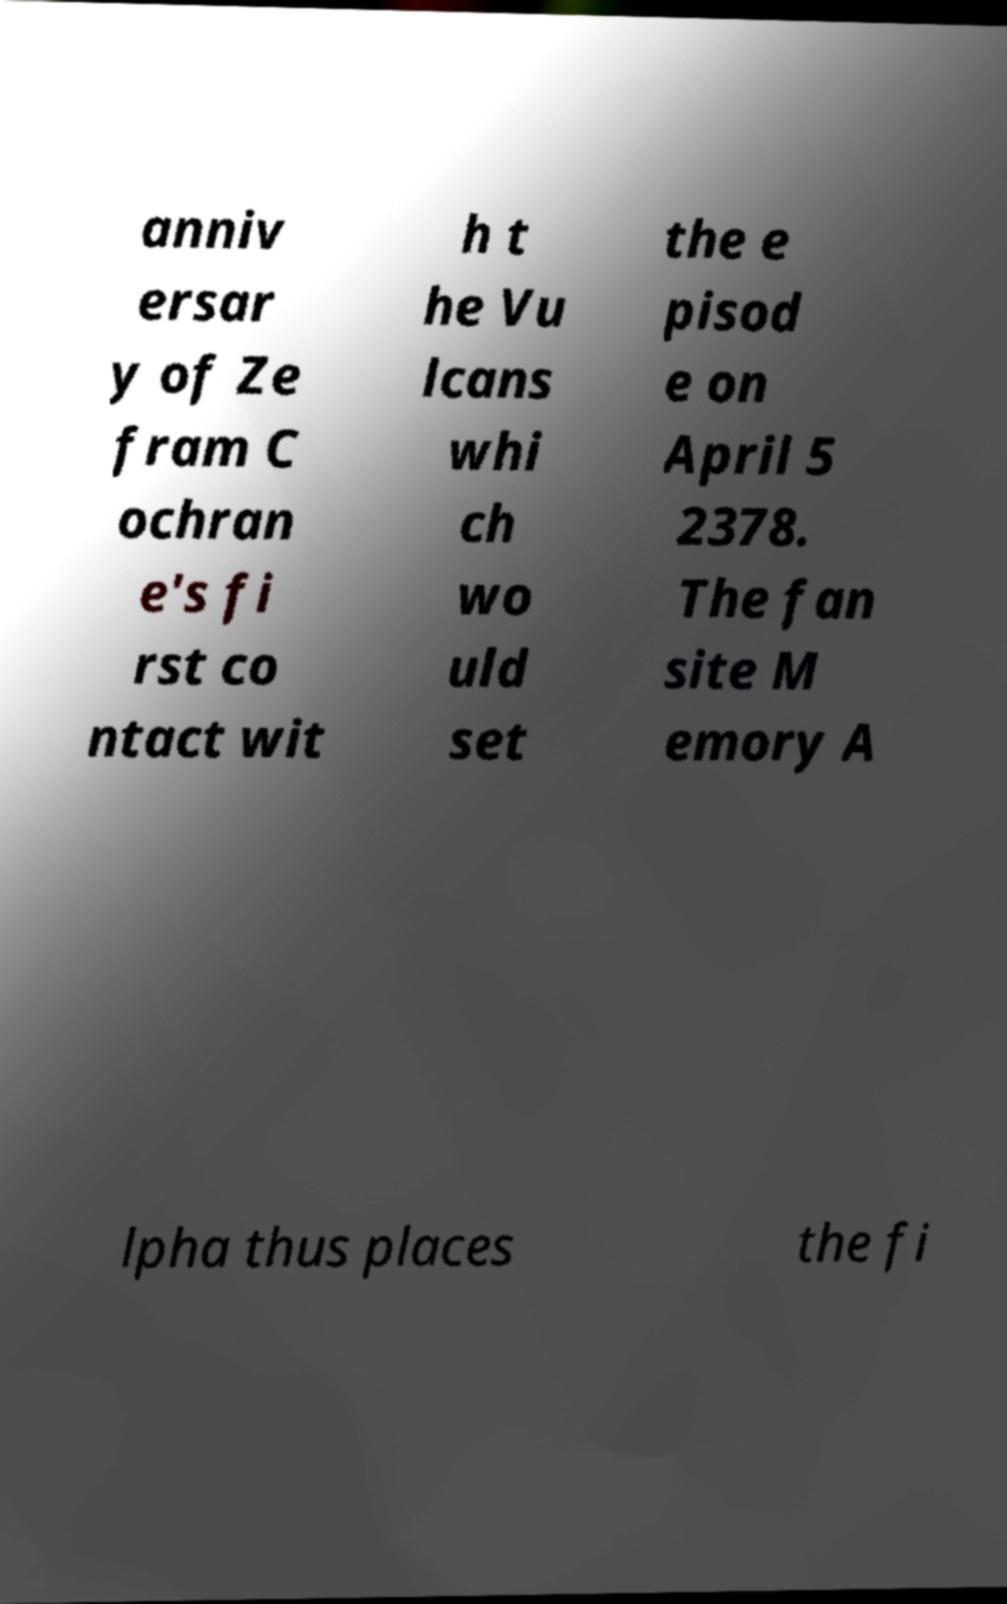There's text embedded in this image that I need extracted. Can you transcribe it verbatim? anniv ersar y of Ze fram C ochran e's fi rst co ntact wit h t he Vu lcans whi ch wo uld set the e pisod e on April 5 2378. The fan site M emory A lpha thus places the fi 